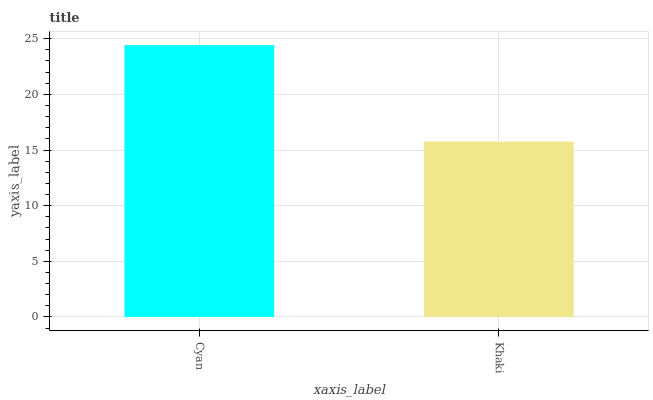Is Khaki the minimum?
Answer yes or no. Yes. Is Cyan the maximum?
Answer yes or no. Yes. Is Khaki the maximum?
Answer yes or no. No. Is Cyan greater than Khaki?
Answer yes or no. Yes. Is Khaki less than Cyan?
Answer yes or no. Yes. Is Khaki greater than Cyan?
Answer yes or no. No. Is Cyan less than Khaki?
Answer yes or no. No. Is Cyan the high median?
Answer yes or no. Yes. Is Khaki the low median?
Answer yes or no. Yes. Is Khaki the high median?
Answer yes or no. No. Is Cyan the low median?
Answer yes or no. No. 